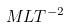<formula> <loc_0><loc_0><loc_500><loc_500>M L T ^ { - 2 }</formula> 